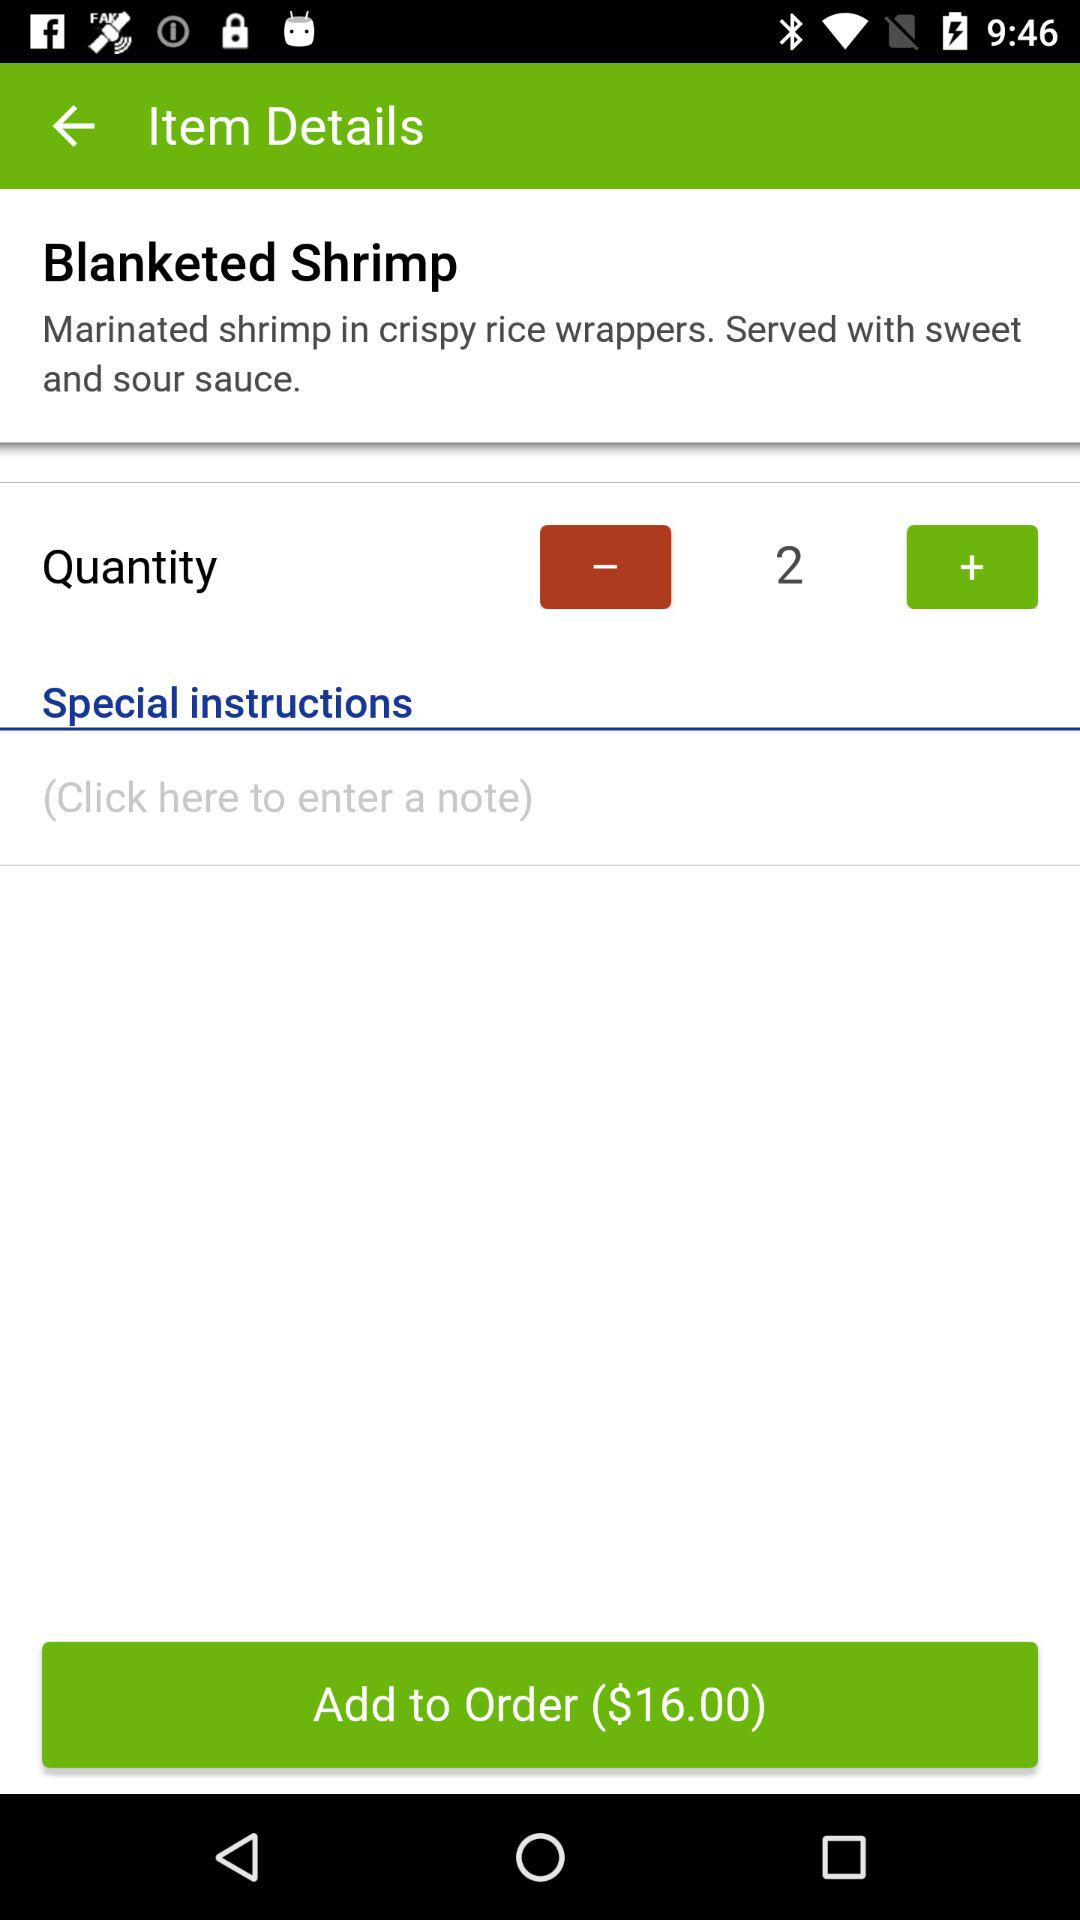What is the quantity of blanketed shrimp? The quantity is 2. 